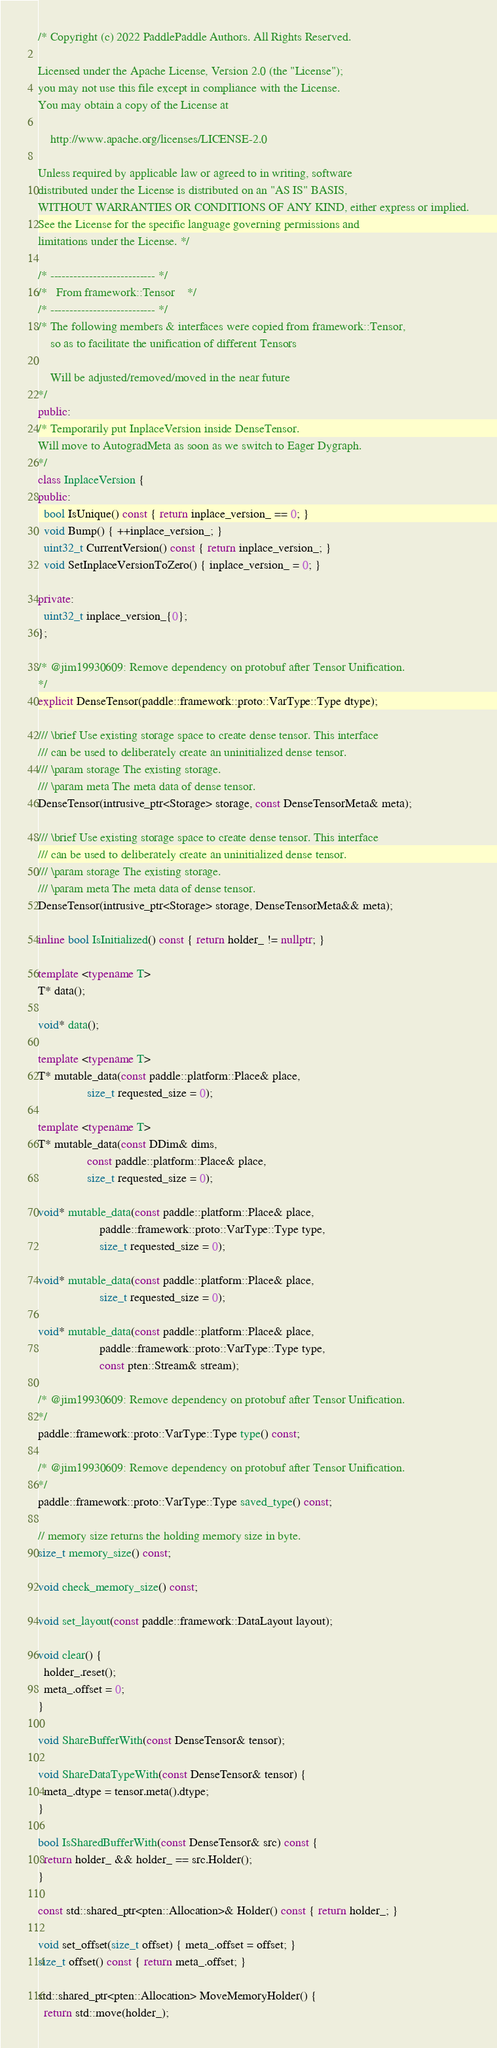<code> <loc_0><loc_0><loc_500><loc_500><_C++_>/* Copyright (c) 2022 PaddlePaddle Authors. All Rights Reserved.

Licensed under the Apache License, Version 2.0 (the "License");
you may not use this file except in compliance with the License.
You may obtain a copy of the License at

    http://www.apache.org/licenses/LICENSE-2.0

Unless required by applicable law or agreed to in writing, software
distributed under the License is distributed on an "AS IS" BASIS,
WITHOUT WARRANTIES OR CONDITIONS OF ANY KIND, either express or implied.
See the License for the specific language governing permissions and
limitations under the License. */

/* --------------------------- */
/*   From framework::Tensor    */
/* --------------------------- */
/* The following members & interfaces were copied from framework::Tensor,
    so as to facilitate the unification of different Tensors

    Will be adjusted/removed/moved in the near future
*/
public:
/* Temporarily put InplaceVersion inside DenseTensor.
Will move to AutogradMeta as soon as we switch to Eager Dygraph.
*/
class InplaceVersion {
public:
  bool IsUnique() const { return inplace_version_ == 0; }
  void Bump() { ++inplace_version_; }
  uint32_t CurrentVersion() const { return inplace_version_; }
  void SetInplaceVersionToZero() { inplace_version_ = 0; }

private:
  uint32_t inplace_version_{0};
};

/* @jim19930609: Remove dependency on protobuf after Tensor Unification.
*/
explicit DenseTensor(paddle::framework::proto::VarType::Type dtype);

/// \brief Use existing storage space to create dense tensor. This interface
/// can be used to deliberately create an uninitialized dense tensor.
/// \param storage The existing storage.
/// \param meta The meta data of dense tensor.
DenseTensor(intrusive_ptr<Storage> storage, const DenseTensorMeta& meta);

/// \brief Use existing storage space to create dense tensor. This interface
/// can be used to deliberately create an uninitialized dense tensor.
/// \param storage The existing storage.
/// \param meta The meta data of dense tensor.
DenseTensor(intrusive_ptr<Storage> storage, DenseTensorMeta&& meta);

inline bool IsInitialized() const { return holder_ != nullptr; }

template <typename T>
T* data();

void* data();

template <typename T>
T* mutable_data(const paddle::platform::Place& place,
                size_t requested_size = 0);

template <typename T>
T* mutable_data(const DDim& dims,
                const paddle::platform::Place& place,
                size_t requested_size = 0);

void* mutable_data(const paddle::platform::Place& place,
                    paddle::framework::proto::VarType::Type type,
                    size_t requested_size = 0);

void* mutable_data(const paddle::platform::Place& place,
                    size_t requested_size = 0);

void* mutable_data(const paddle::platform::Place& place,
                    paddle::framework::proto::VarType::Type type,
                    const pten::Stream& stream);

/* @jim19930609: Remove dependency on protobuf after Tensor Unification.
*/
paddle::framework::proto::VarType::Type type() const;

/* @jim19930609: Remove dependency on protobuf after Tensor Unification.
*/
paddle::framework::proto::VarType::Type saved_type() const;

// memory size returns the holding memory size in byte.
size_t memory_size() const;

void check_memory_size() const;

void set_layout(const paddle::framework::DataLayout layout);

void clear() {
  holder_.reset();
  meta_.offset = 0;
}

void ShareBufferWith(const DenseTensor& tensor);

void ShareDataTypeWith(const DenseTensor& tensor) {
  meta_.dtype = tensor.meta().dtype;
}

bool IsSharedBufferWith(const DenseTensor& src) const {
  return holder_ && holder_ == src.Holder();
}

const std::shared_ptr<pten::Allocation>& Holder() const { return holder_; }

void set_offset(size_t offset) { meta_.offset = offset; }
size_t offset() const { return meta_.offset; }

std::shared_ptr<pten::Allocation> MoveMemoryHolder() {
  return std::move(holder_);</code> 